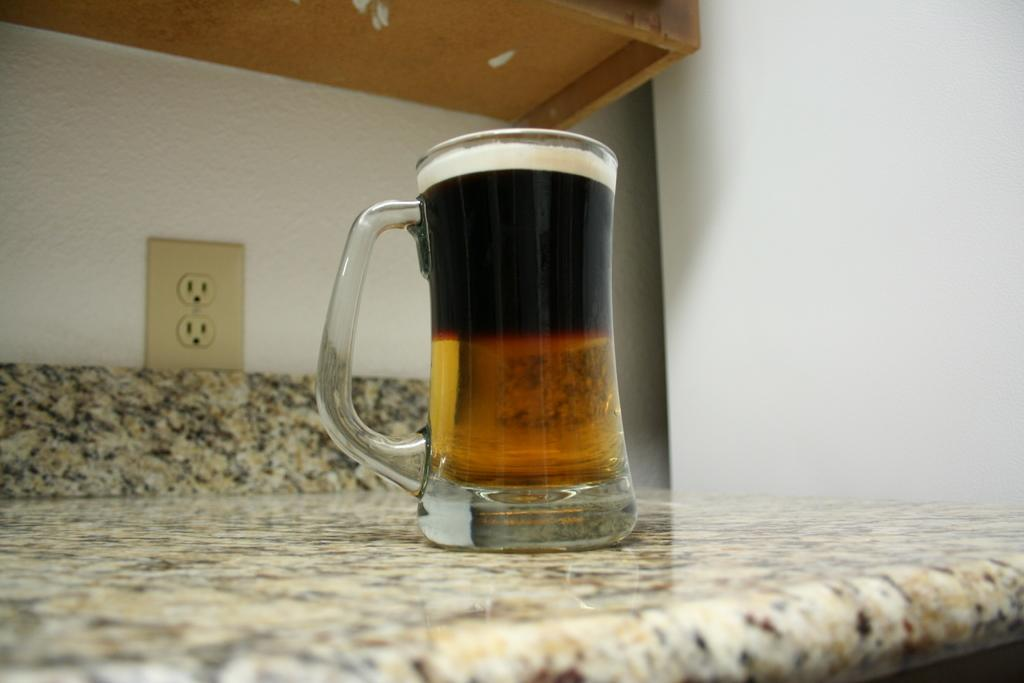What is placed on the cabinet in the image? There is a glass of wine on the cabinet. What can be seen in the background of the image? There is a switch socket and a wall in the background. What type of texture can be seen on the title of the book in the image? There is no book or title present in the image, so it is not possible to determine the texture of a title. 